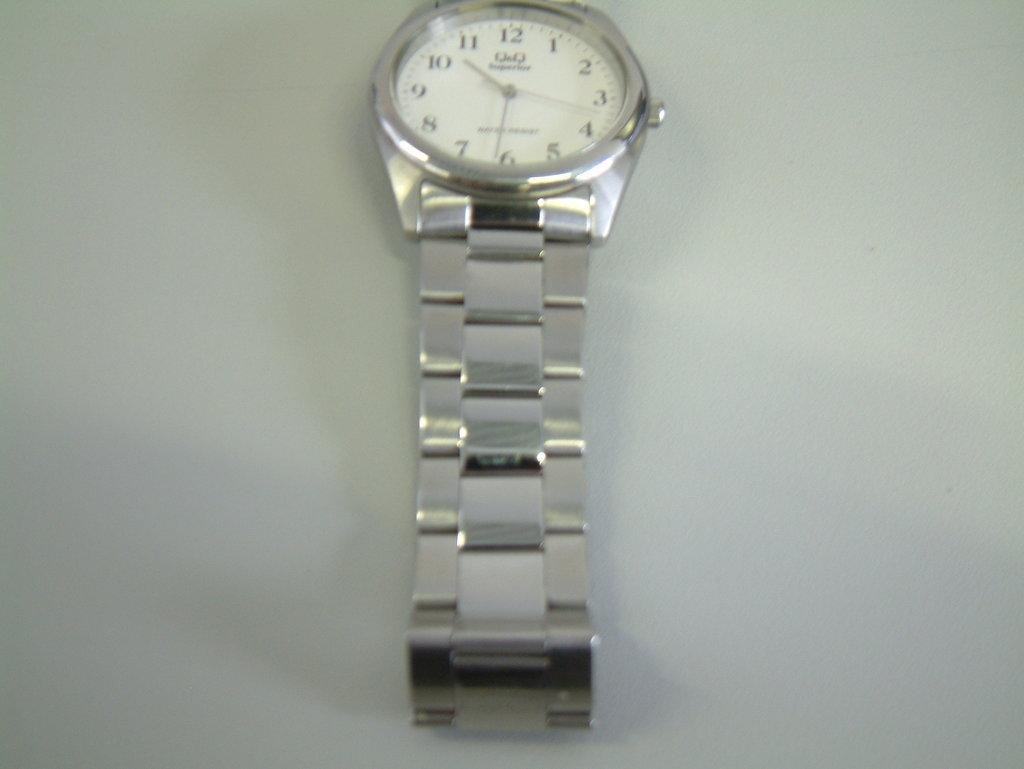Provide a one-sentence caption for the provided image. A silver watch with a white face and silver numbers. 